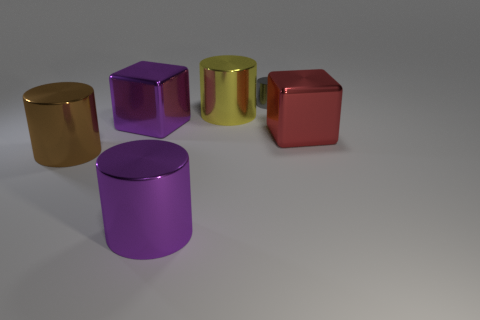Subtract all yellow cylinders. How many cylinders are left? 3 Add 3 purple metallic cubes. How many objects exist? 9 Subtract all brown cylinders. How many cylinders are left? 3 Subtract 1 blocks. How many blocks are left? 1 Subtract all yellow balls. How many yellow cylinders are left? 1 Subtract all large blue cylinders. Subtract all large blocks. How many objects are left? 4 Add 6 red cubes. How many red cubes are left? 7 Add 5 red cylinders. How many red cylinders exist? 5 Subtract 1 red blocks. How many objects are left? 5 Subtract all cylinders. How many objects are left? 2 